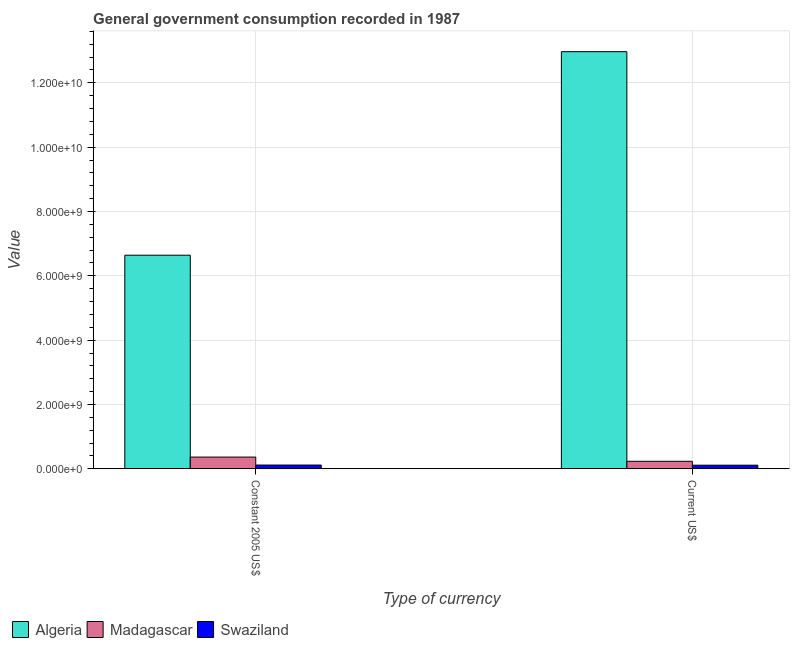How many groups of bars are there?
Make the answer very short. 2. Are the number of bars per tick equal to the number of legend labels?
Offer a very short reply. Yes. Are the number of bars on each tick of the X-axis equal?
Provide a succinct answer. Yes. How many bars are there on the 2nd tick from the left?
Give a very brief answer. 3. What is the label of the 1st group of bars from the left?
Your answer should be compact. Constant 2005 US$. What is the value consumed in constant 2005 us$ in Madagascar?
Your answer should be very brief. 3.66e+08. Across all countries, what is the maximum value consumed in constant 2005 us$?
Give a very brief answer. 6.64e+09. Across all countries, what is the minimum value consumed in current us$?
Offer a terse response. 1.13e+08. In which country was the value consumed in constant 2005 us$ maximum?
Make the answer very short. Algeria. In which country was the value consumed in constant 2005 us$ minimum?
Offer a very short reply. Swaziland. What is the total value consumed in constant 2005 us$ in the graph?
Your answer should be compact. 7.13e+09. What is the difference between the value consumed in constant 2005 us$ in Swaziland and that in Algeria?
Provide a succinct answer. -6.52e+09. What is the difference between the value consumed in current us$ in Algeria and the value consumed in constant 2005 us$ in Swaziland?
Offer a terse response. 1.29e+1. What is the average value consumed in current us$ per country?
Provide a succinct answer. 4.44e+09. What is the difference between the value consumed in constant 2005 us$ and value consumed in current us$ in Algeria?
Make the answer very short. -6.33e+09. In how many countries, is the value consumed in constant 2005 us$ greater than 11600000000 ?
Ensure brevity in your answer.  0. What is the ratio of the value consumed in constant 2005 us$ in Swaziland to that in Madagascar?
Provide a succinct answer. 0.32. Is the value consumed in constant 2005 us$ in Swaziland less than that in Madagascar?
Your answer should be very brief. Yes. In how many countries, is the value consumed in current us$ greater than the average value consumed in current us$ taken over all countries?
Keep it short and to the point. 1. What does the 3rd bar from the left in Constant 2005 US$ represents?
Offer a terse response. Swaziland. What does the 3rd bar from the right in Current US$ represents?
Provide a succinct answer. Algeria. How many bars are there?
Make the answer very short. 6. Are all the bars in the graph horizontal?
Keep it short and to the point. No. What is the difference between two consecutive major ticks on the Y-axis?
Keep it short and to the point. 2.00e+09. Are the values on the major ticks of Y-axis written in scientific E-notation?
Your response must be concise. Yes. What is the title of the graph?
Provide a short and direct response. General government consumption recorded in 1987. Does "Mexico" appear as one of the legend labels in the graph?
Your answer should be compact. No. What is the label or title of the X-axis?
Your answer should be very brief. Type of currency. What is the label or title of the Y-axis?
Keep it short and to the point. Value. What is the Value in Algeria in Constant 2005 US$?
Give a very brief answer. 6.64e+09. What is the Value in Madagascar in Constant 2005 US$?
Provide a short and direct response. 3.66e+08. What is the Value of Swaziland in Constant 2005 US$?
Provide a succinct answer. 1.18e+08. What is the Value of Algeria in Current US$?
Provide a short and direct response. 1.30e+1. What is the Value in Madagascar in Current US$?
Keep it short and to the point. 2.34e+08. What is the Value in Swaziland in Current US$?
Make the answer very short. 1.13e+08. Across all Type of currency, what is the maximum Value of Algeria?
Make the answer very short. 1.30e+1. Across all Type of currency, what is the maximum Value in Madagascar?
Keep it short and to the point. 3.66e+08. Across all Type of currency, what is the maximum Value in Swaziland?
Give a very brief answer. 1.18e+08. Across all Type of currency, what is the minimum Value of Algeria?
Offer a terse response. 6.64e+09. Across all Type of currency, what is the minimum Value in Madagascar?
Provide a succinct answer. 2.34e+08. Across all Type of currency, what is the minimum Value of Swaziland?
Keep it short and to the point. 1.13e+08. What is the total Value of Algeria in the graph?
Keep it short and to the point. 1.96e+1. What is the total Value in Madagascar in the graph?
Offer a terse response. 6.00e+08. What is the total Value in Swaziland in the graph?
Give a very brief answer. 2.32e+08. What is the difference between the Value in Algeria in Constant 2005 US$ and that in Current US$?
Your answer should be very brief. -6.33e+09. What is the difference between the Value in Madagascar in Constant 2005 US$ and that in Current US$?
Make the answer very short. 1.32e+08. What is the difference between the Value of Swaziland in Constant 2005 US$ and that in Current US$?
Provide a short and direct response. 4.66e+06. What is the difference between the Value of Algeria in Constant 2005 US$ and the Value of Madagascar in Current US$?
Ensure brevity in your answer.  6.41e+09. What is the difference between the Value of Algeria in Constant 2005 US$ and the Value of Swaziland in Current US$?
Provide a short and direct response. 6.53e+09. What is the difference between the Value in Madagascar in Constant 2005 US$ and the Value in Swaziland in Current US$?
Ensure brevity in your answer.  2.53e+08. What is the average Value of Algeria per Type of currency?
Offer a very short reply. 9.81e+09. What is the average Value of Madagascar per Type of currency?
Give a very brief answer. 3.00e+08. What is the average Value of Swaziland per Type of currency?
Your answer should be compact. 1.16e+08. What is the difference between the Value of Algeria and Value of Madagascar in Constant 2005 US$?
Give a very brief answer. 6.28e+09. What is the difference between the Value in Algeria and Value in Swaziland in Constant 2005 US$?
Give a very brief answer. 6.52e+09. What is the difference between the Value of Madagascar and Value of Swaziland in Constant 2005 US$?
Your answer should be compact. 2.48e+08. What is the difference between the Value of Algeria and Value of Madagascar in Current US$?
Keep it short and to the point. 1.27e+1. What is the difference between the Value in Algeria and Value in Swaziland in Current US$?
Your response must be concise. 1.29e+1. What is the difference between the Value in Madagascar and Value in Swaziland in Current US$?
Your answer should be very brief. 1.21e+08. What is the ratio of the Value in Algeria in Constant 2005 US$ to that in Current US$?
Your answer should be very brief. 0.51. What is the ratio of the Value in Madagascar in Constant 2005 US$ to that in Current US$?
Offer a terse response. 1.56. What is the ratio of the Value of Swaziland in Constant 2005 US$ to that in Current US$?
Your answer should be compact. 1.04. What is the difference between the highest and the second highest Value of Algeria?
Provide a short and direct response. 6.33e+09. What is the difference between the highest and the second highest Value in Madagascar?
Your answer should be very brief. 1.32e+08. What is the difference between the highest and the second highest Value in Swaziland?
Give a very brief answer. 4.66e+06. What is the difference between the highest and the lowest Value in Algeria?
Your answer should be compact. 6.33e+09. What is the difference between the highest and the lowest Value in Madagascar?
Your answer should be very brief. 1.32e+08. What is the difference between the highest and the lowest Value in Swaziland?
Keep it short and to the point. 4.66e+06. 